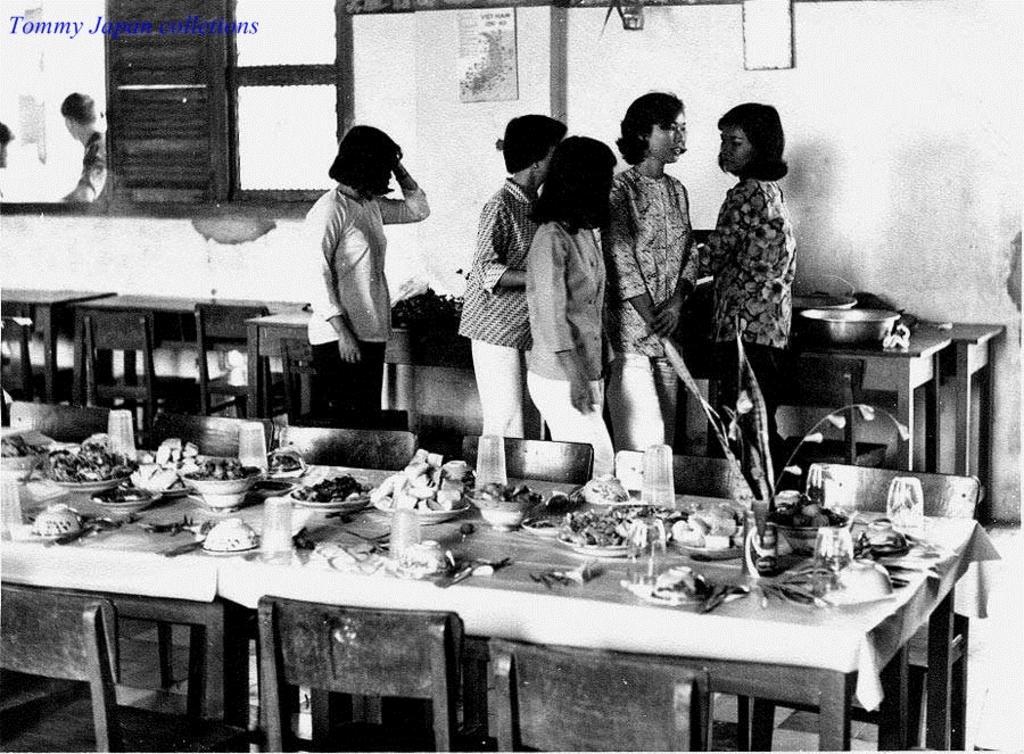Could you give a brief overview of what you see in this image? There is a group of people. There is a table. There is a glass,plate,bowl,fruits and food items on a table. We can see in background window,poster,wall. 